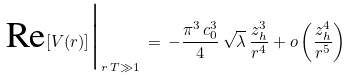<formula> <loc_0><loc_0><loc_500><loc_500>\text {Re} [ V ( r ) ] \Big | _ { r \, T \gg 1 } \, = \, - \frac { \pi ^ { 3 } \, c _ { 0 } ^ { 3 } } { 4 } \, \sqrt { \lambda } \, \frac { z _ { h } ^ { 3 } } { r ^ { 4 } } + o \left ( \frac { z _ { h } ^ { 4 } } { r ^ { 5 } } \right )</formula> 